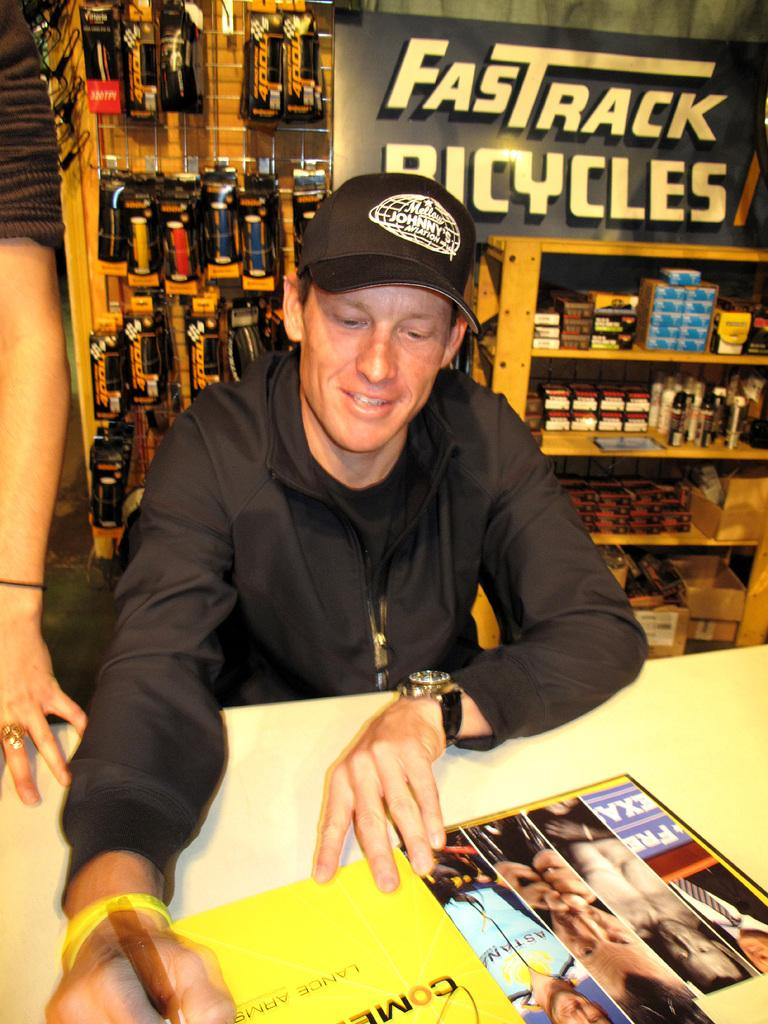Provide a one-sentence caption for the provided image. A young man in the Fastrack Bicycles store looks at some photos as he pages through a magazine. 